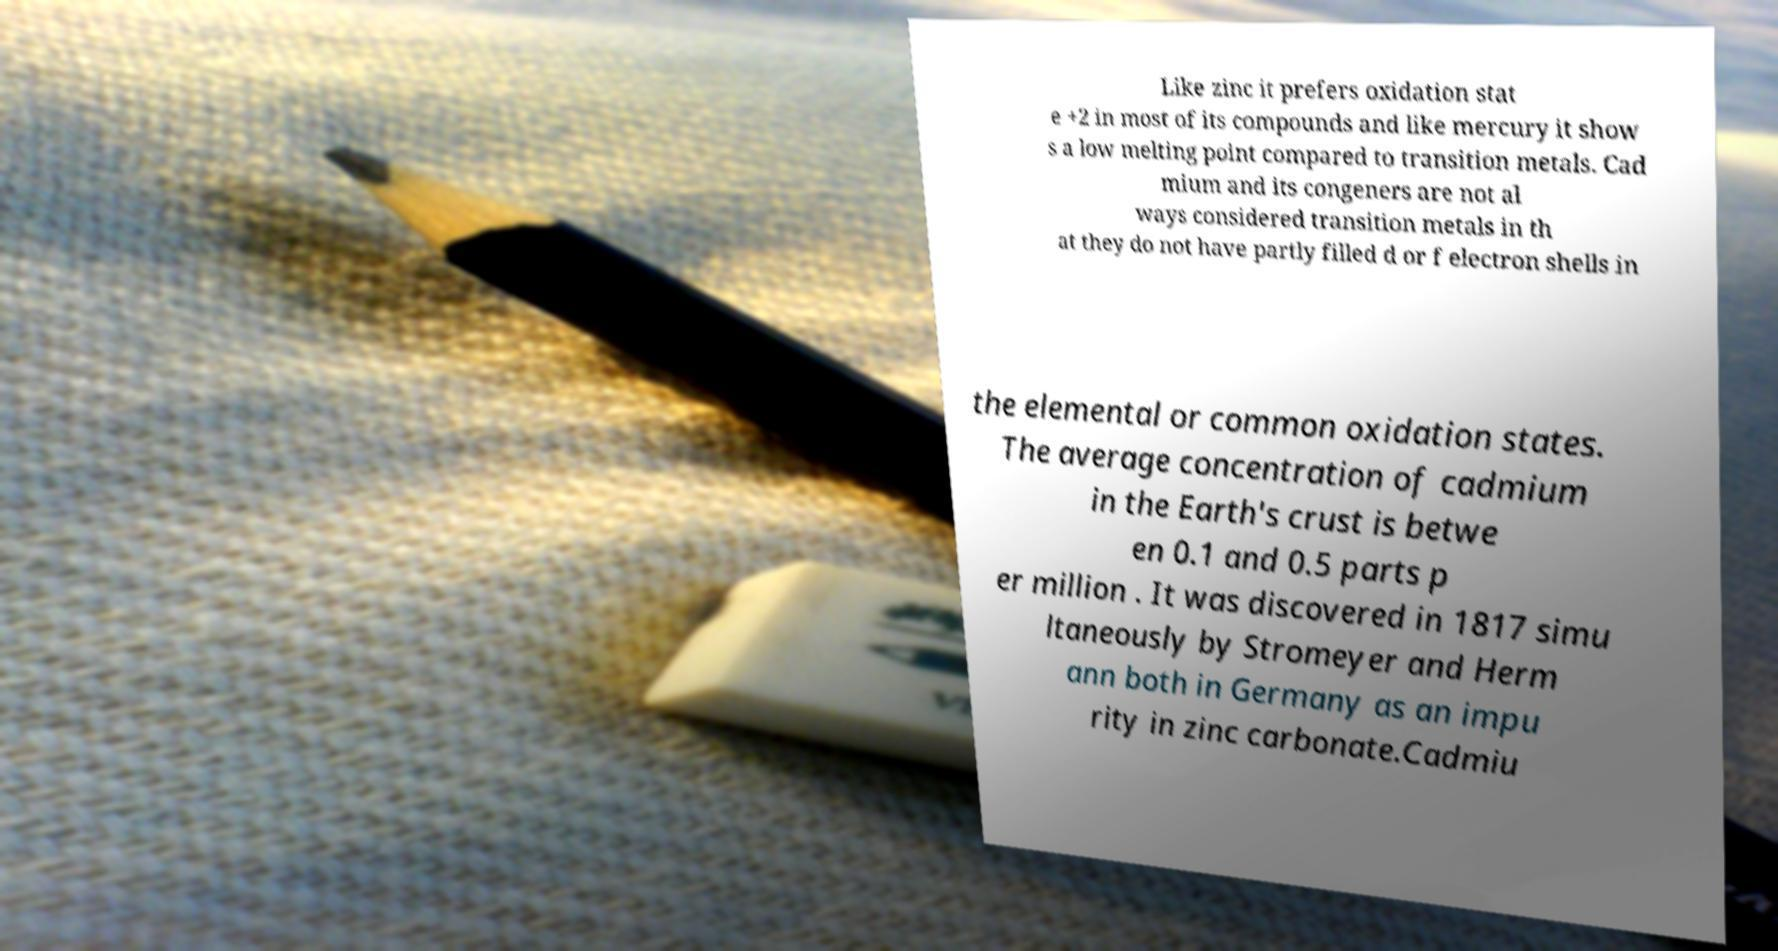There's text embedded in this image that I need extracted. Can you transcribe it verbatim? Like zinc it prefers oxidation stat e +2 in most of its compounds and like mercury it show s a low melting point compared to transition metals. Cad mium and its congeners are not al ways considered transition metals in th at they do not have partly filled d or f electron shells in the elemental or common oxidation states. The average concentration of cadmium in the Earth's crust is betwe en 0.1 and 0.5 parts p er million . It was discovered in 1817 simu ltaneously by Stromeyer and Herm ann both in Germany as an impu rity in zinc carbonate.Cadmiu 